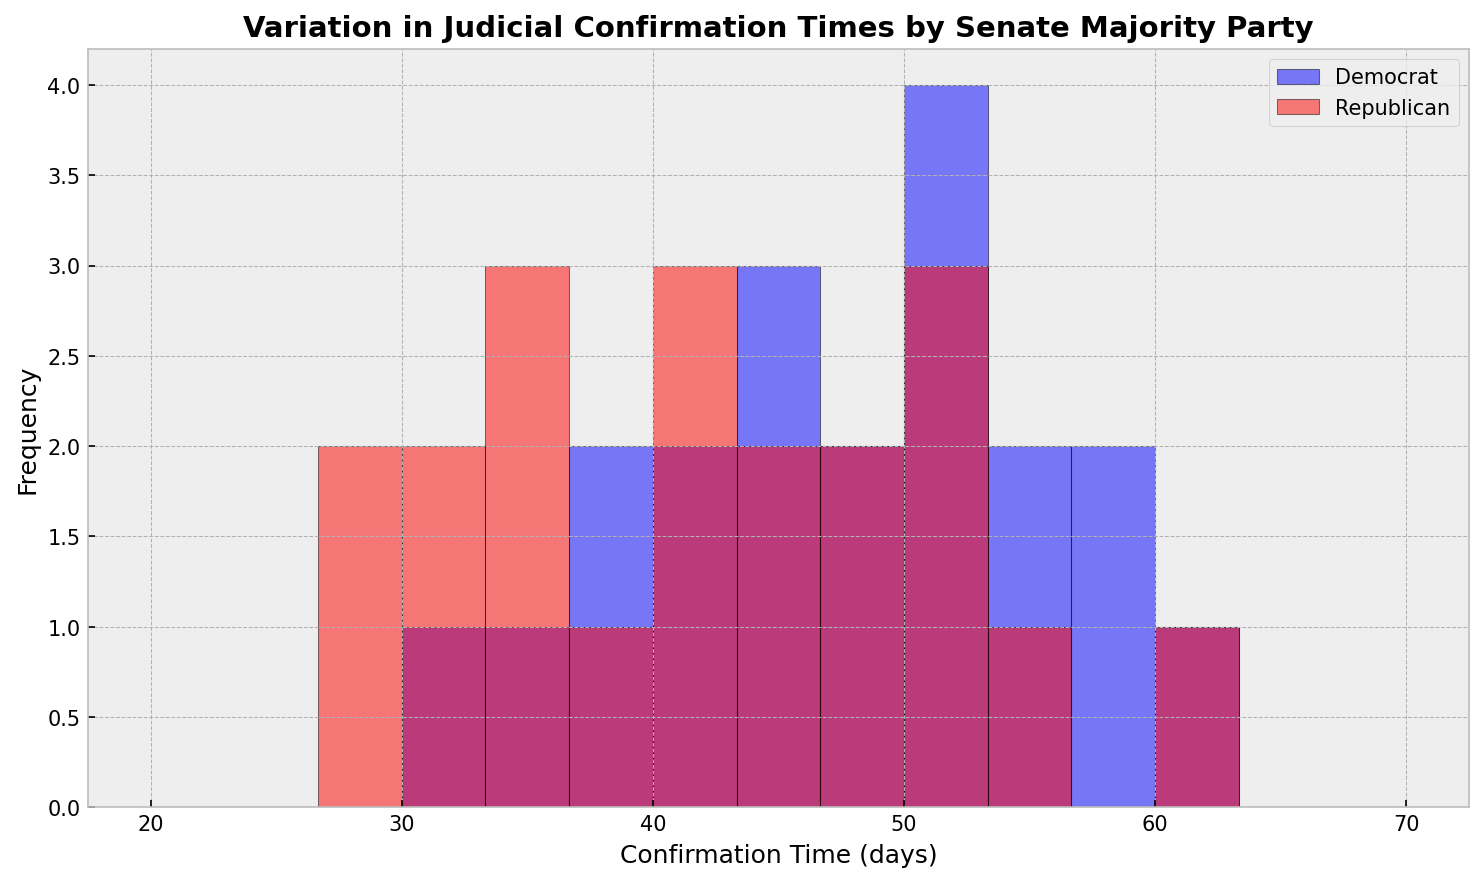Which Senate majority party has higher frequencies for shorter confirmation times? When looking at the bars towards the lower end of the x-axis (shorter confirmation times), the red bars (Republican) tend to have higher frequencies compared to the blue bars (Democrat).
Answer: Republican In which range does the highest frequency occur for Democratic Senate majorities? Observing the blue bars, the highest frequency occurs in the 50-55 days range.
Answer: 50-55 days Which Senate majority has a broader range of confirmation times? The lengths of the bars for both the Democrat (blue) and Republican (red) groups show that Democrats extend more towards higher confirmation times compared to Republicans, who have more values towards the lower end.
Answer: Democrat Are there any confirmation times with the same frequency for both parties? By comparing the heights of the red and blue bars, one can see that for the 32-34 days range and 50-52 days range, both parties show similar frequencies.
Answer: Yes Which Senate majority party has more confirmation times in the 40-45 day range? The frequency for the blue bars (Democrats) is higher in the 40-45 day range compared to the red bars (Republicans).
Answer: Democrat 